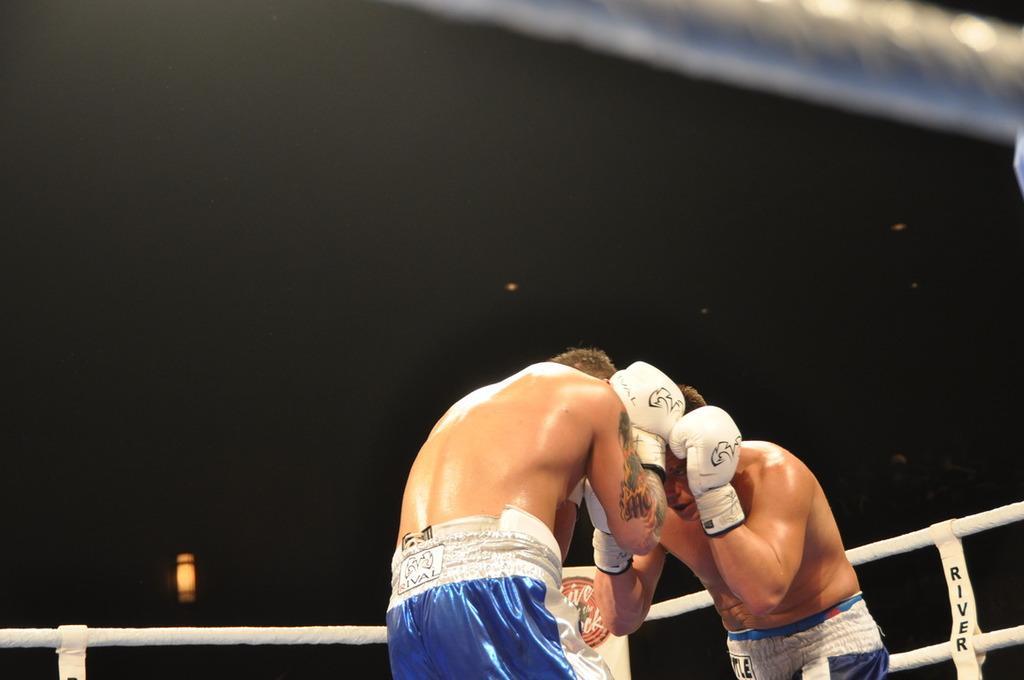Could you give a brief overview of what you see in this image? In the foreground of the picture we can see two persons in a boxing ring. At the top it is dark. 